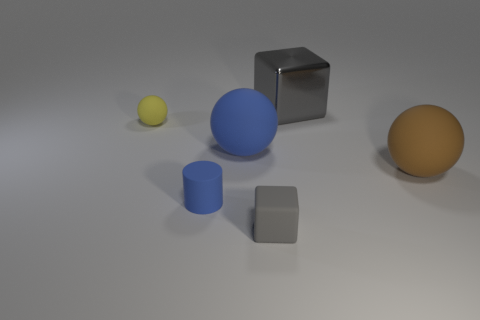Add 3 blue things. How many objects exist? 9 Subtract all cylinders. How many objects are left? 5 Add 6 tiny spheres. How many tiny spheres are left? 7 Add 3 big gray rubber objects. How many big gray rubber objects exist? 3 Subtract 0 purple balls. How many objects are left? 6 Subtract all tiny matte cubes. Subtract all large balls. How many objects are left? 3 